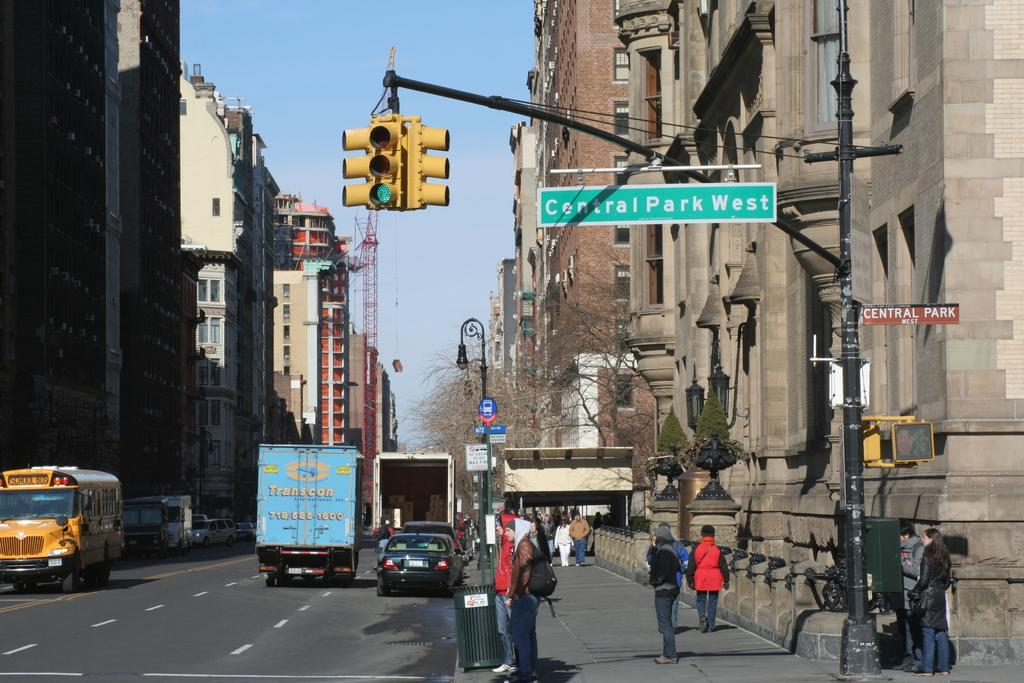<image>
Render a clear and concise summary of the photo. At intersections a street sign will tell the people around what street they are on. 